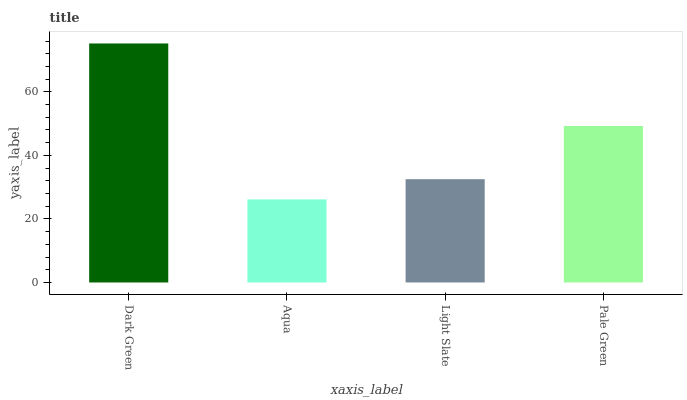Is Aqua the minimum?
Answer yes or no. Yes. Is Dark Green the maximum?
Answer yes or no. Yes. Is Light Slate the minimum?
Answer yes or no. No. Is Light Slate the maximum?
Answer yes or no. No. Is Light Slate greater than Aqua?
Answer yes or no. Yes. Is Aqua less than Light Slate?
Answer yes or no. Yes. Is Aqua greater than Light Slate?
Answer yes or no. No. Is Light Slate less than Aqua?
Answer yes or no. No. Is Pale Green the high median?
Answer yes or no. Yes. Is Light Slate the low median?
Answer yes or no. Yes. Is Light Slate the high median?
Answer yes or no. No. Is Dark Green the low median?
Answer yes or no. No. 